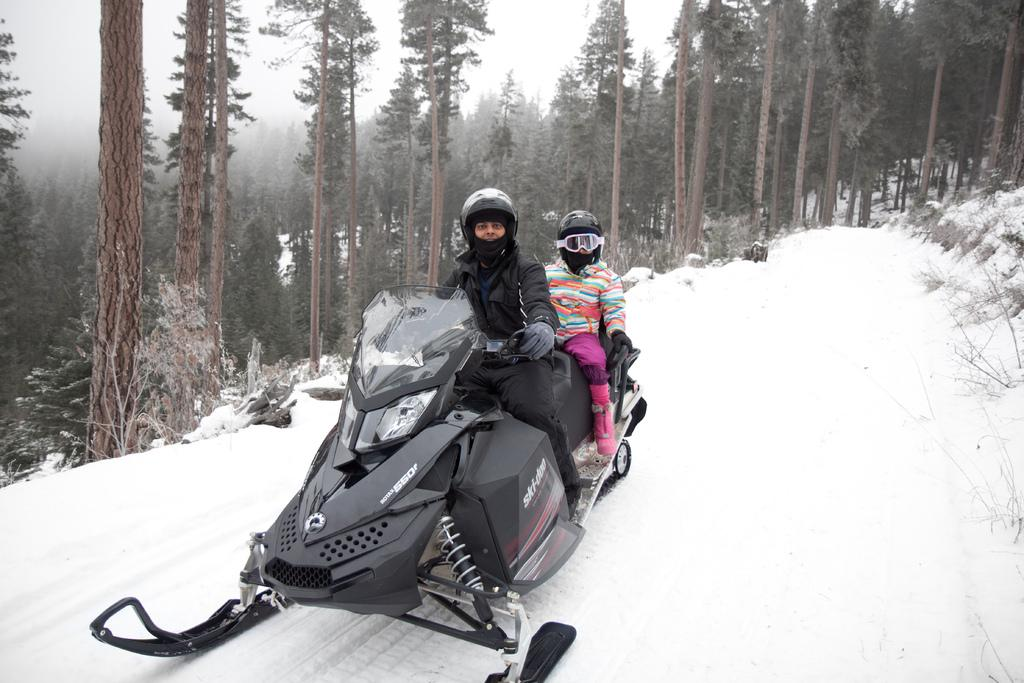How many people are in the image? There are two persons in the image. What are the persons wearing on their heads? The persons are wearing helmets. What are the persons sitting on in the image? The persons are sitting on a ski vehicle. Where is the ski vehicle located? The ski vehicle is on the sand. What can be seen in the background of the image? There are trees in the background of the image. What is the condition of the trees in the image? The trees are covered with snow. What type of ground can be seen in the image? The ground in the image is sand, not a different type of ground. What town is visible in the image? There is no town visible in the image; it features a ski vehicle on the sand with trees in the background. 